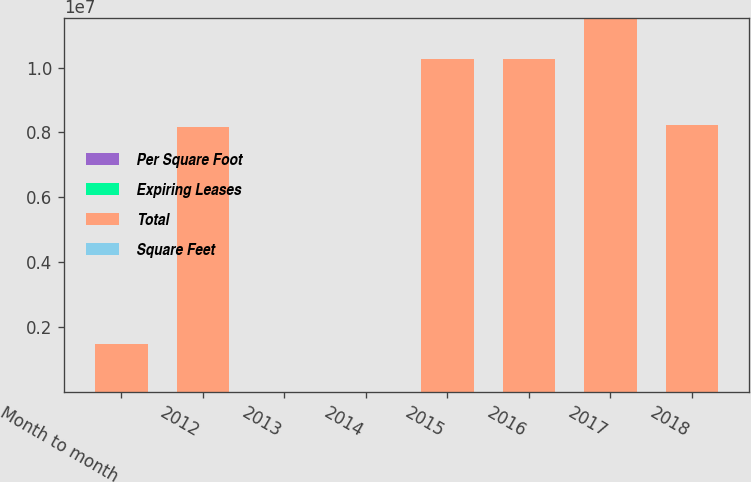<chart> <loc_0><loc_0><loc_500><loc_500><stacked_bar_chart><ecel><fcel>Month to month<fcel>2012<fcel>2013<fcel>2014<fcel>2015<fcel>2016<fcel>2017<fcel>2018<nl><fcel>Per Square Foot<fcel>17<fcel>78<fcel>120<fcel>133<fcel>99<fcel>79<fcel>45<fcel>33<nl><fcel>Expiring Leases<fcel>1.3<fcel>5.7<fcel>9.2<fcel>9.4<fcel>7<fcel>7.4<fcel>7.7<fcel>5.8<nl><fcel>Total<fcel>1.477e+06<fcel>8.16e+06<fcel>36.17<fcel>36.17<fcel>1.0254e+07<fcel>1.0268e+07<fcel>1.1516e+07<fcel>8.222e+06<nl><fcel>Square Feet<fcel>27.51<fcel>35.79<fcel>37.53<fcel>35.33<fcel>36.55<fcel>34.52<fcel>37.07<fcel>35.39<nl></chart> 